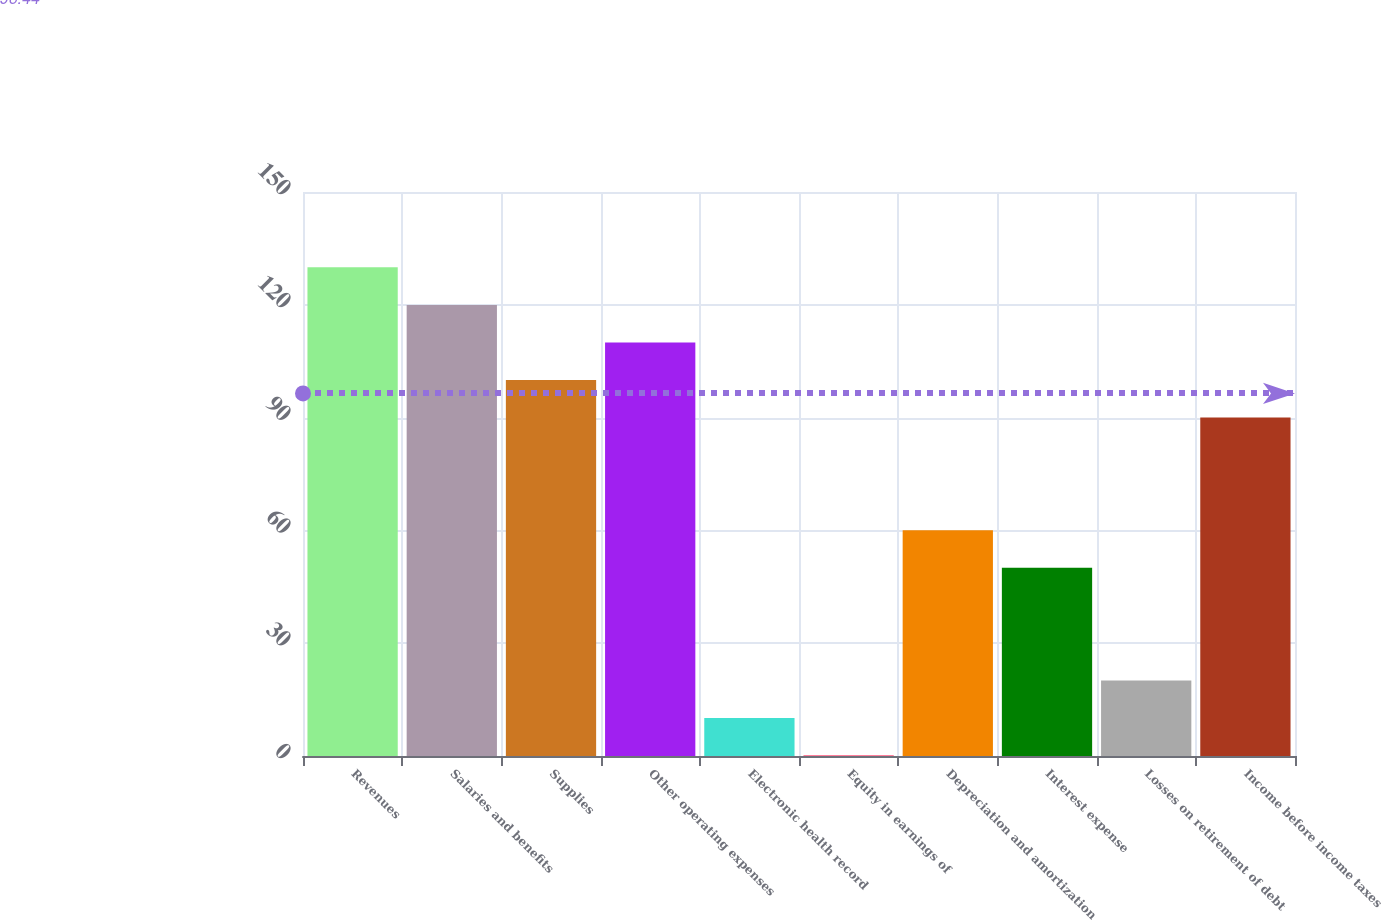<chart> <loc_0><loc_0><loc_500><loc_500><bar_chart><fcel>Revenues<fcel>Salaries and benefits<fcel>Supplies<fcel>Other operating expenses<fcel>Electronic health record<fcel>Equity in earnings of<fcel>Depreciation and amortization<fcel>Interest expense<fcel>Losses on retirement of debt<fcel>Income before income taxes<nl><fcel>129.97<fcel>119.98<fcel>100<fcel>109.99<fcel>10.09<fcel>0.1<fcel>60.04<fcel>50.05<fcel>20.08<fcel>90.01<nl></chart> 